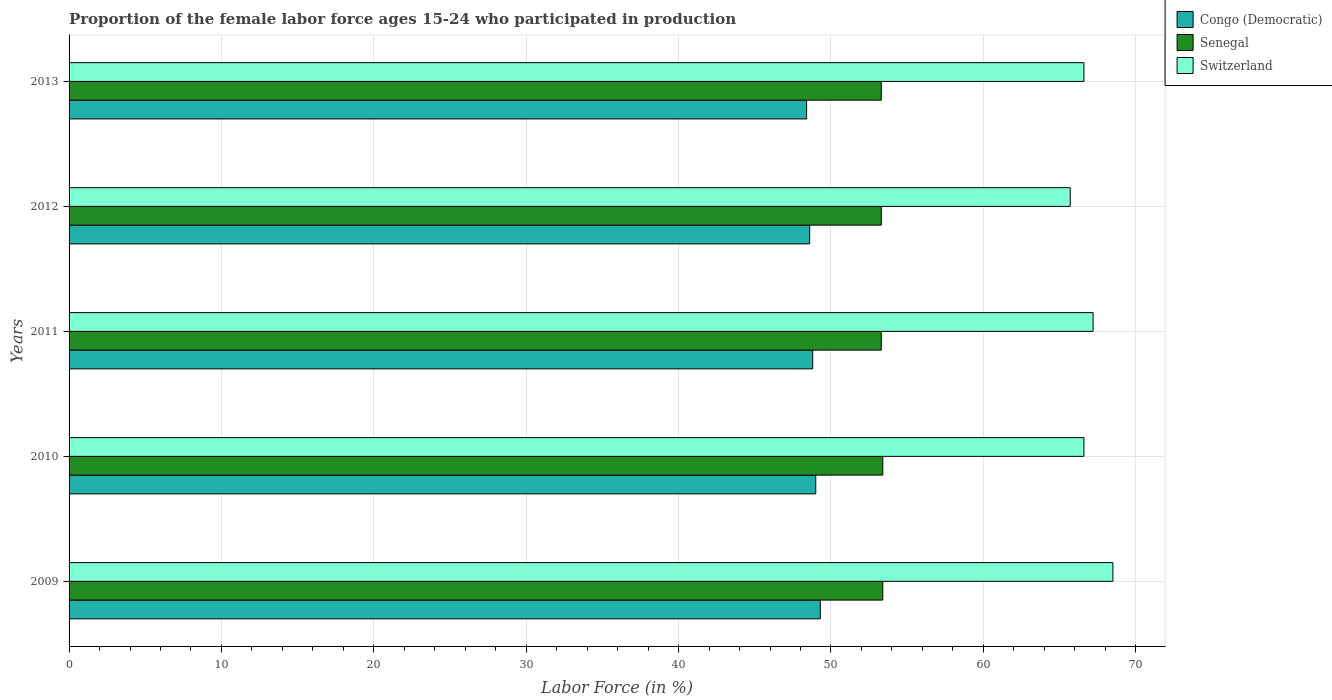Are the number of bars per tick equal to the number of legend labels?
Your answer should be compact. Yes. Are the number of bars on each tick of the Y-axis equal?
Offer a very short reply. Yes. What is the label of the 4th group of bars from the top?
Make the answer very short. 2010. What is the proportion of the female labor force who participated in production in Senegal in 2009?
Offer a very short reply. 53.4. Across all years, what is the maximum proportion of the female labor force who participated in production in Switzerland?
Provide a succinct answer. 68.5. Across all years, what is the minimum proportion of the female labor force who participated in production in Switzerland?
Your answer should be compact. 65.7. In which year was the proportion of the female labor force who participated in production in Switzerland maximum?
Make the answer very short. 2009. What is the total proportion of the female labor force who participated in production in Senegal in the graph?
Give a very brief answer. 266.7. What is the difference between the proportion of the female labor force who participated in production in Congo (Democratic) in 2010 and that in 2011?
Provide a short and direct response. 0.2. What is the difference between the proportion of the female labor force who participated in production in Switzerland in 2010 and the proportion of the female labor force who participated in production in Congo (Democratic) in 2012?
Your response must be concise. 18. What is the average proportion of the female labor force who participated in production in Congo (Democratic) per year?
Provide a short and direct response. 48.82. In the year 2013, what is the difference between the proportion of the female labor force who participated in production in Congo (Democratic) and proportion of the female labor force who participated in production in Switzerland?
Provide a succinct answer. -18.2. In how many years, is the proportion of the female labor force who participated in production in Switzerland greater than 54 %?
Give a very brief answer. 5. Is the proportion of the female labor force who participated in production in Congo (Democratic) in 2009 less than that in 2011?
Offer a very short reply. No. What is the difference between the highest and the second highest proportion of the female labor force who participated in production in Switzerland?
Provide a succinct answer. 1.3. What is the difference between the highest and the lowest proportion of the female labor force who participated in production in Congo (Democratic)?
Your answer should be compact. 0.9. What does the 1st bar from the top in 2010 represents?
Offer a terse response. Switzerland. What does the 1st bar from the bottom in 2010 represents?
Offer a very short reply. Congo (Democratic). Are all the bars in the graph horizontal?
Give a very brief answer. Yes. What is the difference between two consecutive major ticks on the X-axis?
Your response must be concise. 10. Does the graph contain any zero values?
Your response must be concise. No. Where does the legend appear in the graph?
Ensure brevity in your answer.  Top right. How many legend labels are there?
Make the answer very short. 3. How are the legend labels stacked?
Give a very brief answer. Vertical. What is the title of the graph?
Your response must be concise. Proportion of the female labor force ages 15-24 who participated in production. What is the label or title of the Y-axis?
Offer a terse response. Years. What is the Labor Force (in %) of Congo (Democratic) in 2009?
Offer a terse response. 49.3. What is the Labor Force (in %) in Senegal in 2009?
Give a very brief answer. 53.4. What is the Labor Force (in %) of Switzerland in 2009?
Offer a very short reply. 68.5. What is the Labor Force (in %) in Senegal in 2010?
Give a very brief answer. 53.4. What is the Labor Force (in %) of Switzerland in 2010?
Offer a very short reply. 66.6. What is the Labor Force (in %) of Congo (Democratic) in 2011?
Offer a very short reply. 48.8. What is the Labor Force (in %) of Senegal in 2011?
Your response must be concise. 53.3. What is the Labor Force (in %) in Switzerland in 2011?
Your answer should be compact. 67.2. What is the Labor Force (in %) in Congo (Democratic) in 2012?
Ensure brevity in your answer.  48.6. What is the Labor Force (in %) in Senegal in 2012?
Your answer should be very brief. 53.3. What is the Labor Force (in %) in Switzerland in 2012?
Make the answer very short. 65.7. What is the Labor Force (in %) in Congo (Democratic) in 2013?
Keep it short and to the point. 48.4. What is the Labor Force (in %) of Senegal in 2013?
Make the answer very short. 53.3. What is the Labor Force (in %) in Switzerland in 2013?
Your response must be concise. 66.6. Across all years, what is the maximum Labor Force (in %) in Congo (Democratic)?
Your response must be concise. 49.3. Across all years, what is the maximum Labor Force (in %) in Senegal?
Keep it short and to the point. 53.4. Across all years, what is the maximum Labor Force (in %) of Switzerland?
Your answer should be compact. 68.5. Across all years, what is the minimum Labor Force (in %) in Congo (Democratic)?
Keep it short and to the point. 48.4. Across all years, what is the minimum Labor Force (in %) in Senegal?
Offer a very short reply. 53.3. Across all years, what is the minimum Labor Force (in %) in Switzerland?
Provide a succinct answer. 65.7. What is the total Labor Force (in %) in Congo (Democratic) in the graph?
Provide a succinct answer. 244.1. What is the total Labor Force (in %) in Senegal in the graph?
Ensure brevity in your answer.  266.7. What is the total Labor Force (in %) in Switzerland in the graph?
Keep it short and to the point. 334.6. What is the difference between the Labor Force (in %) in Senegal in 2009 and that in 2010?
Provide a short and direct response. 0. What is the difference between the Labor Force (in %) of Switzerland in 2009 and that in 2011?
Provide a short and direct response. 1.3. What is the difference between the Labor Force (in %) in Congo (Democratic) in 2009 and that in 2012?
Ensure brevity in your answer.  0.7. What is the difference between the Labor Force (in %) of Senegal in 2009 and that in 2012?
Provide a succinct answer. 0.1. What is the difference between the Labor Force (in %) in Switzerland in 2009 and that in 2013?
Provide a succinct answer. 1.9. What is the difference between the Labor Force (in %) of Congo (Democratic) in 2010 and that in 2011?
Your answer should be very brief. 0.2. What is the difference between the Labor Force (in %) in Switzerland in 2010 and that in 2011?
Make the answer very short. -0.6. What is the difference between the Labor Force (in %) in Switzerland in 2010 and that in 2012?
Provide a succinct answer. 0.9. What is the difference between the Labor Force (in %) in Senegal in 2011 and that in 2012?
Your response must be concise. 0. What is the difference between the Labor Force (in %) in Senegal in 2011 and that in 2013?
Offer a terse response. 0. What is the difference between the Labor Force (in %) in Switzerland in 2011 and that in 2013?
Your answer should be very brief. 0.6. What is the difference between the Labor Force (in %) in Congo (Democratic) in 2012 and that in 2013?
Ensure brevity in your answer.  0.2. What is the difference between the Labor Force (in %) of Switzerland in 2012 and that in 2013?
Your answer should be very brief. -0.9. What is the difference between the Labor Force (in %) of Congo (Democratic) in 2009 and the Labor Force (in %) of Senegal in 2010?
Offer a terse response. -4.1. What is the difference between the Labor Force (in %) of Congo (Democratic) in 2009 and the Labor Force (in %) of Switzerland in 2010?
Offer a terse response. -17.3. What is the difference between the Labor Force (in %) of Congo (Democratic) in 2009 and the Labor Force (in %) of Switzerland in 2011?
Your answer should be very brief. -17.9. What is the difference between the Labor Force (in %) in Congo (Democratic) in 2009 and the Labor Force (in %) in Senegal in 2012?
Offer a terse response. -4. What is the difference between the Labor Force (in %) of Congo (Democratic) in 2009 and the Labor Force (in %) of Switzerland in 2012?
Give a very brief answer. -16.4. What is the difference between the Labor Force (in %) of Senegal in 2009 and the Labor Force (in %) of Switzerland in 2012?
Offer a very short reply. -12.3. What is the difference between the Labor Force (in %) of Congo (Democratic) in 2009 and the Labor Force (in %) of Switzerland in 2013?
Make the answer very short. -17.3. What is the difference between the Labor Force (in %) in Congo (Democratic) in 2010 and the Labor Force (in %) in Switzerland in 2011?
Your answer should be compact. -18.2. What is the difference between the Labor Force (in %) in Congo (Democratic) in 2010 and the Labor Force (in %) in Senegal in 2012?
Provide a short and direct response. -4.3. What is the difference between the Labor Force (in %) of Congo (Democratic) in 2010 and the Labor Force (in %) of Switzerland in 2012?
Your response must be concise. -16.7. What is the difference between the Labor Force (in %) in Congo (Democratic) in 2010 and the Labor Force (in %) in Senegal in 2013?
Your answer should be very brief. -4.3. What is the difference between the Labor Force (in %) of Congo (Democratic) in 2010 and the Labor Force (in %) of Switzerland in 2013?
Keep it short and to the point. -17.6. What is the difference between the Labor Force (in %) of Senegal in 2010 and the Labor Force (in %) of Switzerland in 2013?
Provide a short and direct response. -13.2. What is the difference between the Labor Force (in %) of Congo (Democratic) in 2011 and the Labor Force (in %) of Switzerland in 2012?
Offer a very short reply. -16.9. What is the difference between the Labor Force (in %) in Senegal in 2011 and the Labor Force (in %) in Switzerland in 2012?
Your answer should be compact. -12.4. What is the difference between the Labor Force (in %) of Congo (Democratic) in 2011 and the Labor Force (in %) of Senegal in 2013?
Offer a terse response. -4.5. What is the difference between the Labor Force (in %) of Congo (Democratic) in 2011 and the Labor Force (in %) of Switzerland in 2013?
Your answer should be very brief. -17.8. What is the difference between the Labor Force (in %) in Congo (Democratic) in 2012 and the Labor Force (in %) in Switzerland in 2013?
Ensure brevity in your answer.  -18. What is the average Labor Force (in %) in Congo (Democratic) per year?
Your answer should be very brief. 48.82. What is the average Labor Force (in %) of Senegal per year?
Offer a terse response. 53.34. What is the average Labor Force (in %) in Switzerland per year?
Offer a very short reply. 66.92. In the year 2009, what is the difference between the Labor Force (in %) in Congo (Democratic) and Labor Force (in %) in Switzerland?
Your answer should be compact. -19.2. In the year 2009, what is the difference between the Labor Force (in %) in Senegal and Labor Force (in %) in Switzerland?
Provide a succinct answer. -15.1. In the year 2010, what is the difference between the Labor Force (in %) of Congo (Democratic) and Labor Force (in %) of Senegal?
Your answer should be very brief. -4.4. In the year 2010, what is the difference between the Labor Force (in %) of Congo (Democratic) and Labor Force (in %) of Switzerland?
Provide a short and direct response. -17.6. In the year 2010, what is the difference between the Labor Force (in %) of Senegal and Labor Force (in %) of Switzerland?
Provide a short and direct response. -13.2. In the year 2011, what is the difference between the Labor Force (in %) in Congo (Democratic) and Labor Force (in %) in Switzerland?
Provide a short and direct response. -18.4. In the year 2011, what is the difference between the Labor Force (in %) of Senegal and Labor Force (in %) of Switzerland?
Provide a short and direct response. -13.9. In the year 2012, what is the difference between the Labor Force (in %) of Congo (Democratic) and Labor Force (in %) of Switzerland?
Your answer should be very brief. -17.1. In the year 2012, what is the difference between the Labor Force (in %) of Senegal and Labor Force (in %) of Switzerland?
Make the answer very short. -12.4. In the year 2013, what is the difference between the Labor Force (in %) of Congo (Democratic) and Labor Force (in %) of Senegal?
Keep it short and to the point. -4.9. In the year 2013, what is the difference between the Labor Force (in %) of Congo (Democratic) and Labor Force (in %) of Switzerland?
Ensure brevity in your answer.  -18.2. What is the ratio of the Labor Force (in %) in Switzerland in 2009 to that in 2010?
Ensure brevity in your answer.  1.03. What is the ratio of the Labor Force (in %) in Congo (Democratic) in 2009 to that in 2011?
Provide a short and direct response. 1.01. What is the ratio of the Labor Force (in %) in Switzerland in 2009 to that in 2011?
Give a very brief answer. 1.02. What is the ratio of the Labor Force (in %) of Congo (Democratic) in 2009 to that in 2012?
Your response must be concise. 1.01. What is the ratio of the Labor Force (in %) in Switzerland in 2009 to that in 2012?
Your answer should be very brief. 1.04. What is the ratio of the Labor Force (in %) in Congo (Democratic) in 2009 to that in 2013?
Your response must be concise. 1.02. What is the ratio of the Labor Force (in %) in Senegal in 2009 to that in 2013?
Ensure brevity in your answer.  1. What is the ratio of the Labor Force (in %) of Switzerland in 2009 to that in 2013?
Make the answer very short. 1.03. What is the ratio of the Labor Force (in %) in Congo (Democratic) in 2010 to that in 2012?
Offer a terse response. 1.01. What is the ratio of the Labor Force (in %) in Switzerland in 2010 to that in 2012?
Make the answer very short. 1.01. What is the ratio of the Labor Force (in %) of Congo (Democratic) in 2010 to that in 2013?
Ensure brevity in your answer.  1.01. What is the ratio of the Labor Force (in %) of Switzerland in 2010 to that in 2013?
Give a very brief answer. 1. What is the ratio of the Labor Force (in %) in Switzerland in 2011 to that in 2012?
Make the answer very short. 1.02. What is the ratio of the Labor Force (in %) in Congo (Democratic) in 2011 to that in 2013?
Make the answer very short. 1.01. What is the ratio of the Labor Force (in %) of Switzerland in 2011 to that in 2013?
Your response must be concise. 1.01. What is the ratio of the Labor Force (in %) of Congo (Democratic) in 2012 to that in 2013?
Ensure brevity in your answer.  1. What is the ratio of the Labor Force (in %) of Switzerland in 2012 to that in 2013?
Offer a very short reply. 0.99. What is the difference between the highest and the second highest Labor Force (in %) in Congo (Democratic)?
Ensure brevity in your answer.  0.3. What is the difference between the highest and the second highest Labor Force (in %) in Senegal?
Give a very brief answer. 0. What is the difference between the highest and the second highest Labor Force (in %) of Switzerland?
Make the answer very short. 1.3. 